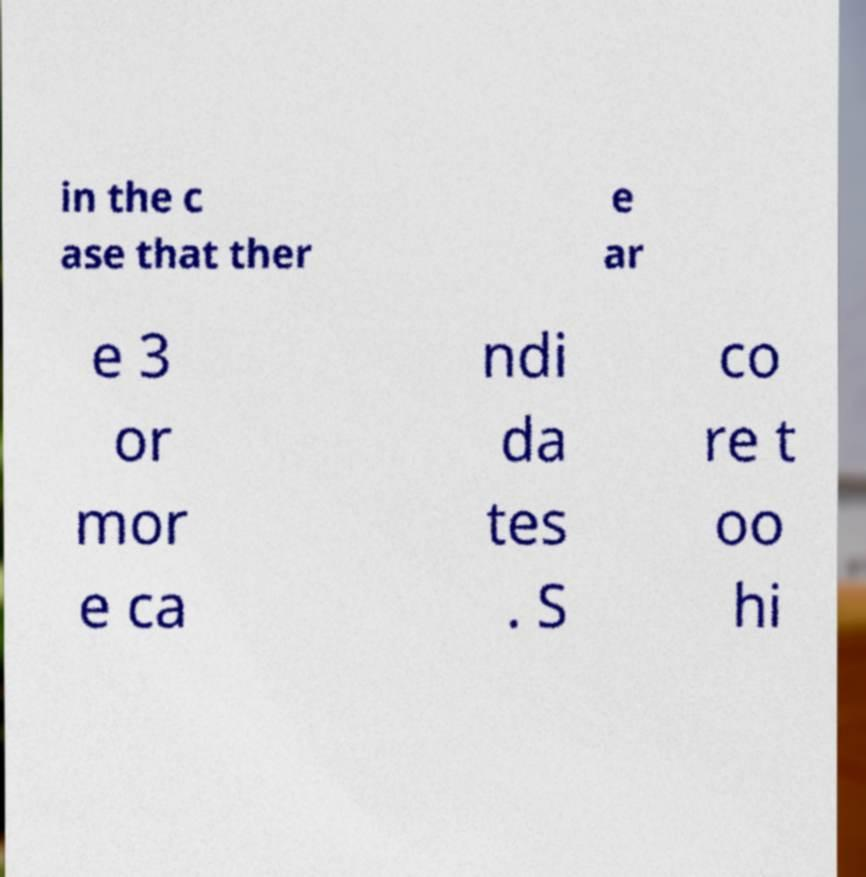Please identify and transcribe the text found in this image. in the c ase that ther e ar e 3 or mor e ca ndi da tes . S co re t oo hi 